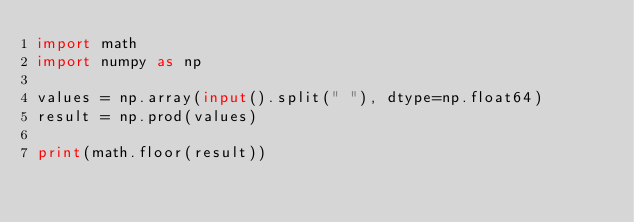Convert code to text. <code><loc_0><loc_0><loc_500><loc_500><_Python_>import math
import numpy as np

values = np.array(input().split(" "), dtype=np.float64)
result = np.prod(values)

print(math.floor(result))</code> 